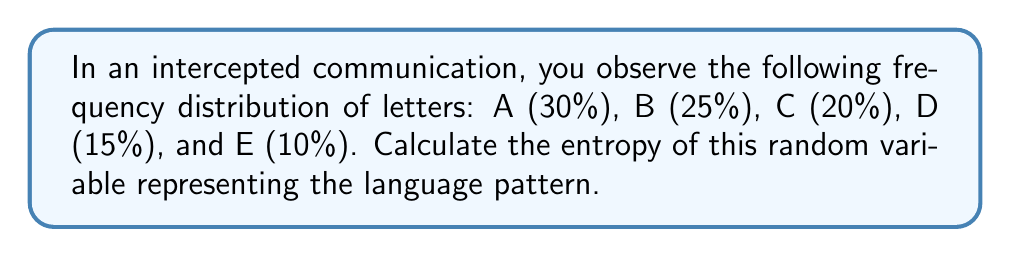What is the answer to this math problem? To calculate the entropy of a discrete random variable, we use the formula:

$$ H(X) = -\sum_{i=1}^n p_i \log_2(p_i) $$

Where $p_i$ is the probability of each outcome.

Step 1: Convert percentages to probabilities
A: 0.30, B: 0.25, C: 0.20, D: 0.15, E: 0.10

Step 2: Calculate each term in the sum
For A: $-0.30 \log_2(0.30) = 0.5211$
For B: $-0.25 \log_2(0.25) = 0.5000$
For C: $-0.20 \log_2(0.20) = 0.4644$
For D: $-0.15 \log_2(0.15) = 0.4101$
For E: $-0.10 \log_2(0.10) = 0.3322$

Step 3: Sum all terms
$H(X) = 0.5211 + 0.5000 + 0.4644 + 0.4101 + 0.3322 = 2.2278$

The entropy is approximately 2.2278 bits.
Answer: 2.2278 bits 